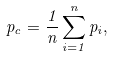<formula> <loc_0><loc_0><loc_500><loc_500>p _ { c } = { \frac { 1 } { n } } \sum _ { i = 1 } ^ { n } p _ { i } ,</formula> 